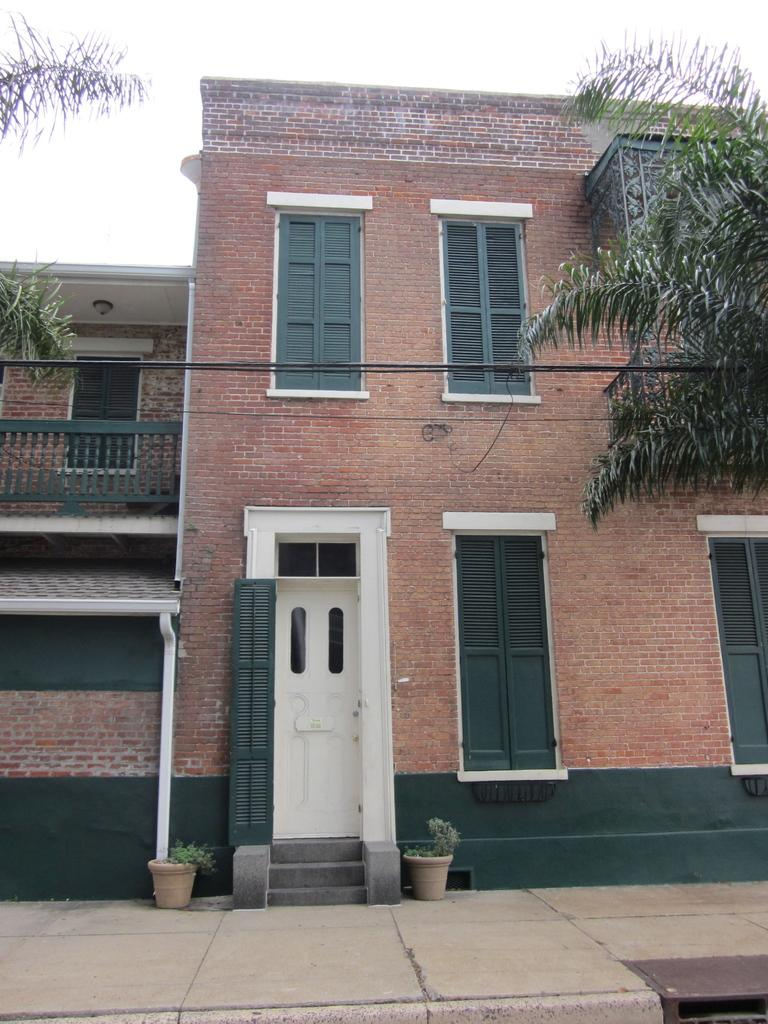What type of structure is present in the image? There is a building in the image. What can be seen in front of the building? There are trees and plants in front of the building. What is visible in the background of the image? The sky is visible in the background of the image. What type of bed can be seen in the image? There is no bed present in the image; it features a building with trees and plants in front of it. 